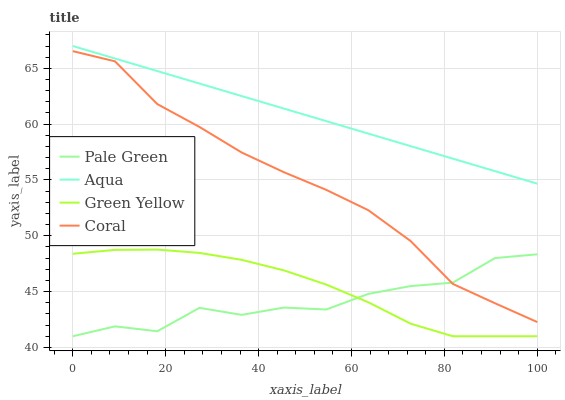Does Pale Green have the minimum area under the curve?
Answer yes or no. Yes. Does Aqua have the maximum area under the curve?
Answer yes or no. Yes. Does Aqua have the minimum area under the curve?
Answer yes or no. No. Does Pale Green have the maximum area under the curve?
Answer yes or no. No. Is Aqua the smoothest?
Answer yes or no. Yes. Is Pale Green the roughest?
Answer yes or no. Yes. Is Pale Green the smoothest?
Answer yes or no. No. Is Aqua the roughest?
Answer yes or no. No. Does Green Yellow have the lowest value?
Answer yes or no. Yes. Does Aqua have the lowest value?
Answer yes or no. No. Does Aqua have the highest value?
Answer yes or no. Yes. Does Pale Green have the highest value?
Answer yes or no. No. Is Pale Green less than Aqua?
Answer yes or no. Yes. Is Aqua greater than Pale Green?
Answer yes or no. Yes. Does Green Yellow intersect Pale Green?
Answer yes or no. Yes. Is Green Yellow less than Pale Green?
Answer yes or no. No. Is Green Yellow greater than Pale Green?
Answer yes or no. No. Does Pale Green intersect Aqua?
Answer yes or no. No. 